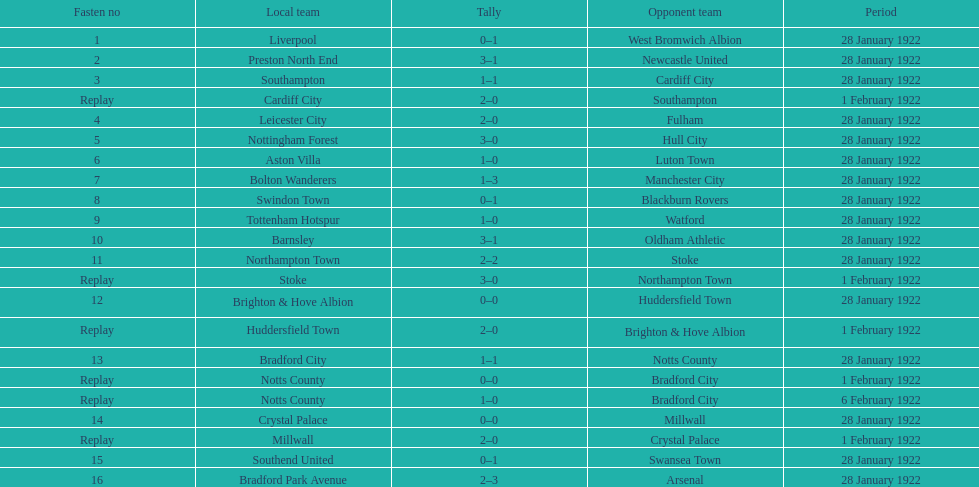What date did they play before feb 1? 28 January 1922. 